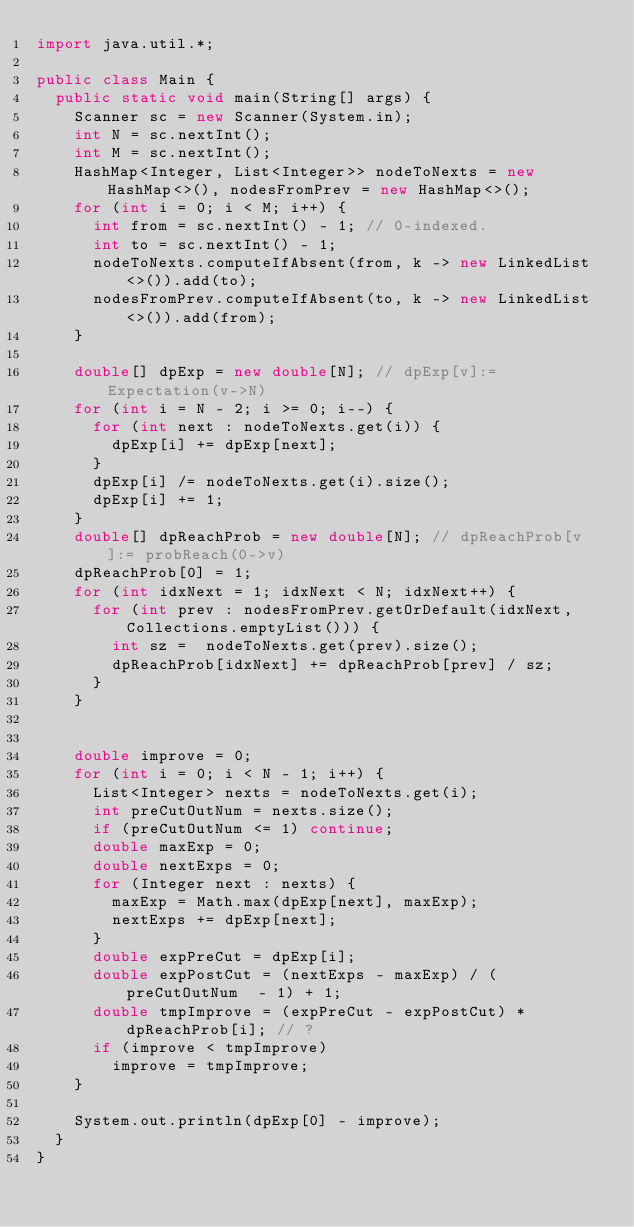Convert code to text. <code><loc_0><loc_0><loc_500><loc_500><_Java_>import java.util.*;

public class Main {
  public static void main(String[] args) {
    Scanner sc = new Scanner(System.in);
    int N = sc.nextInt();
    int M = sc.nextInt();
    HashMap<Integer, List<Integer>> nodeToNexts = new HashMap<>(), nodesFromPrev = new HashMap<>();
    for (int i = 0; i < M; i++) {
      int from = sc.nextInt() - 1; // 0-indexed.
      int to = sc.nextInt() - 1;
      nodeToNexts.computeIfAbsent(from, k -> new LinkedList<>()).add(to);
      nodesFromPrev.computeIfAbsent(to, k -> new LinkedList<>()).add(from);
    }

    double[] dpExp = new double[N]; // dpExp[v]:= Expectation(v->N)
    for (int i = N - 2; i >= 0; i--) {
      for (int next : nodeToNexts.get(i)) {
        dpExp[i] += dpExp[next];
      }
      dpExp[i] /= nodeToNexts.get(i).size();
      dpExp[i] += 1;
    }
    double[] dpReachProb = new double[N]; // dpReachProb[v]:= probReach(0->v)
    dpReachProb[0] = 1;
    for (int idxNext = 1; idxNext < N; idxNext++) {
      for (int prev : nodesFromPrev.getOrDefault(idxNext, Collections.emptyList())) {
        int sz =  nodeToNexts.get(prev).size();
        dpReachProb[idxNext] += dpReachProb[prev] / sz;
      }
    }


    double improve = 0;
    for (int i = 0; i < N - 1; i++) {
      List<Integer> nexts = nodeToNexts.get(i);
      int preCutOutNum = nexts.size();
      if (preCutOutNum <= 1) continue;
      double maxExp = 0;
      double nextExps = 0;
      for (Integer next : nexts) {
        maxExp = Math.max(dpExp[next], maxExp);
        nextExps += dpExp[next];
      }
      double expPreCut = dpExp[i];
      double expPostCut = (nextExps - maxExp) / (preCutOutNum  - 1) + 1;
      double tmpImprove = (expPreCut - expPostCut) * dpReachProb[i]; // ?
      if (improve < tmpImprove)
        improve = tmpImprove;
    }

    System.out.println(dpExp[0] - improve);
  }
}
</code> 